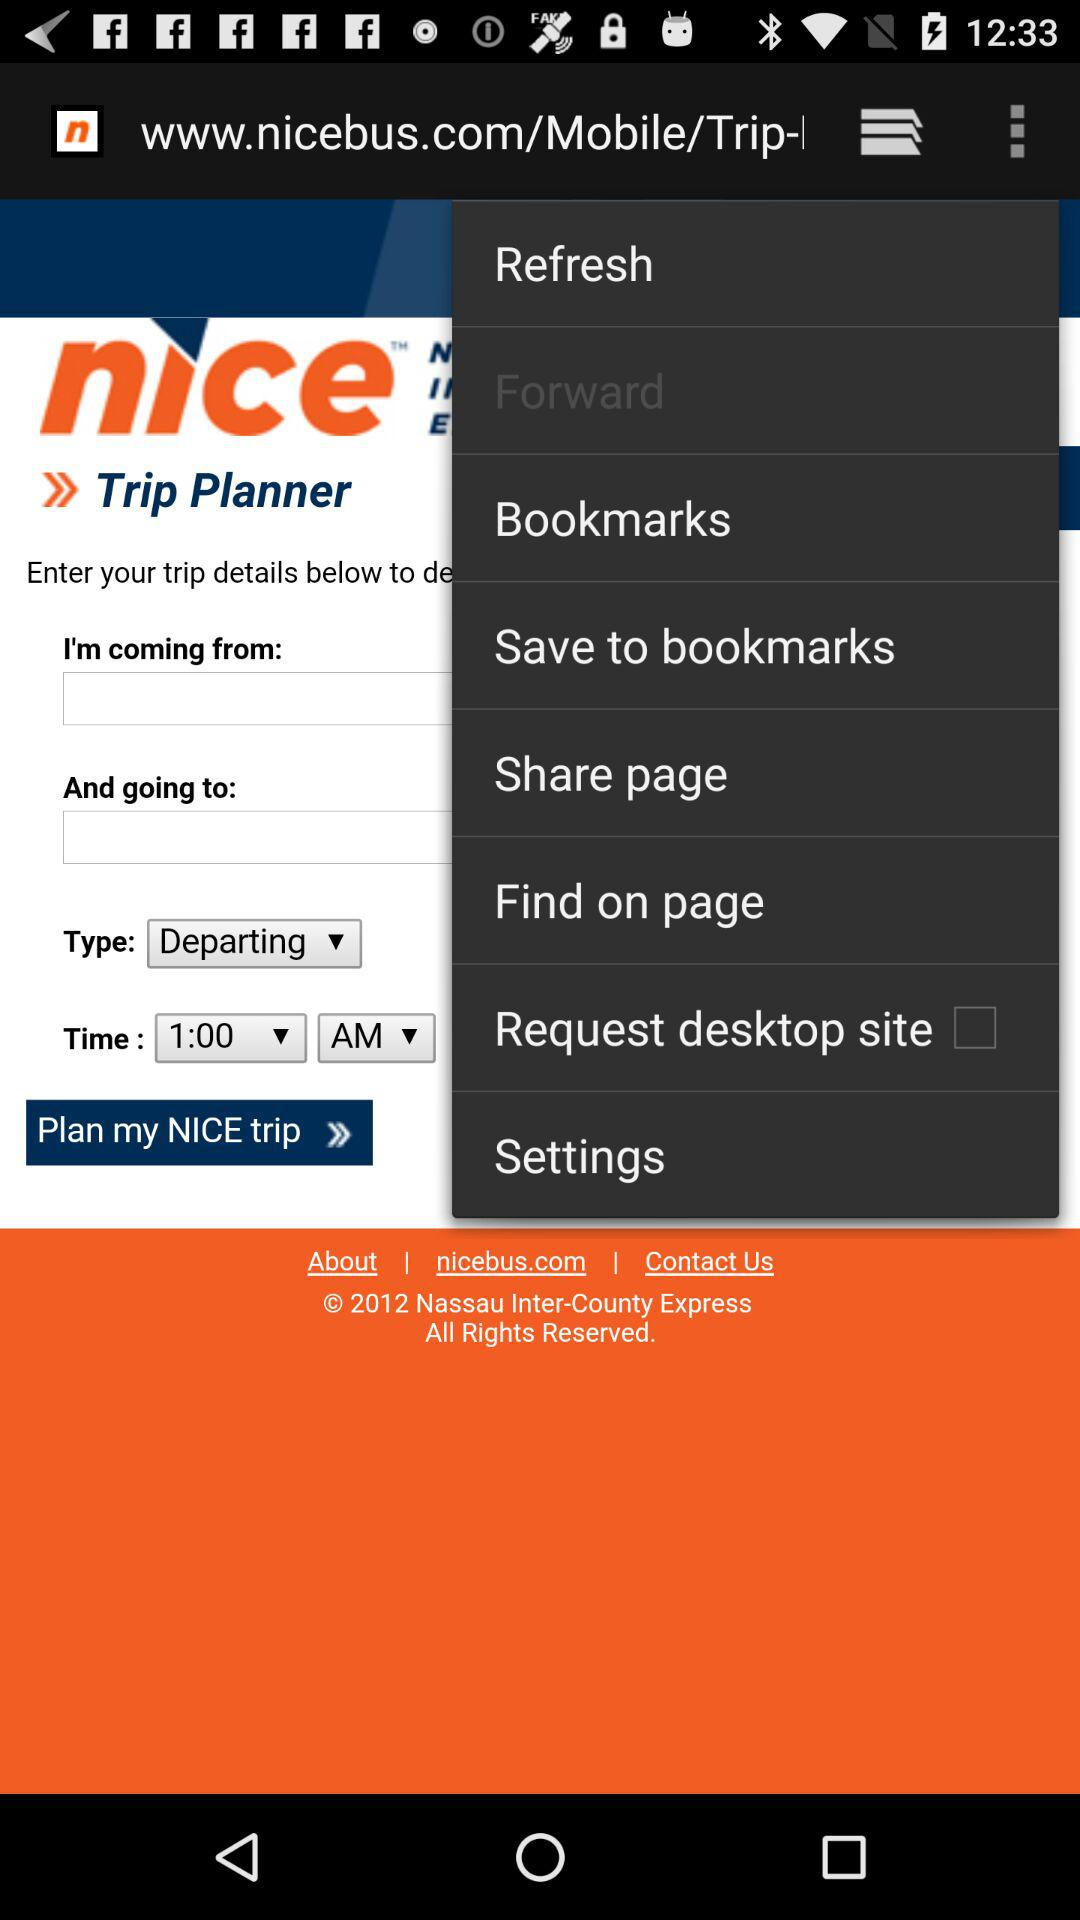What is the "Departing" time? The "Departing" time is 1:00 AM. 